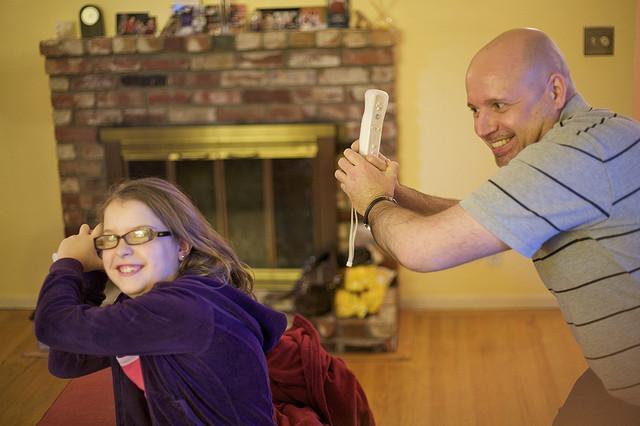How many handbags are there?
Give a very brief answer. 2. How many people are there?
Give a very brief answer. 2. 